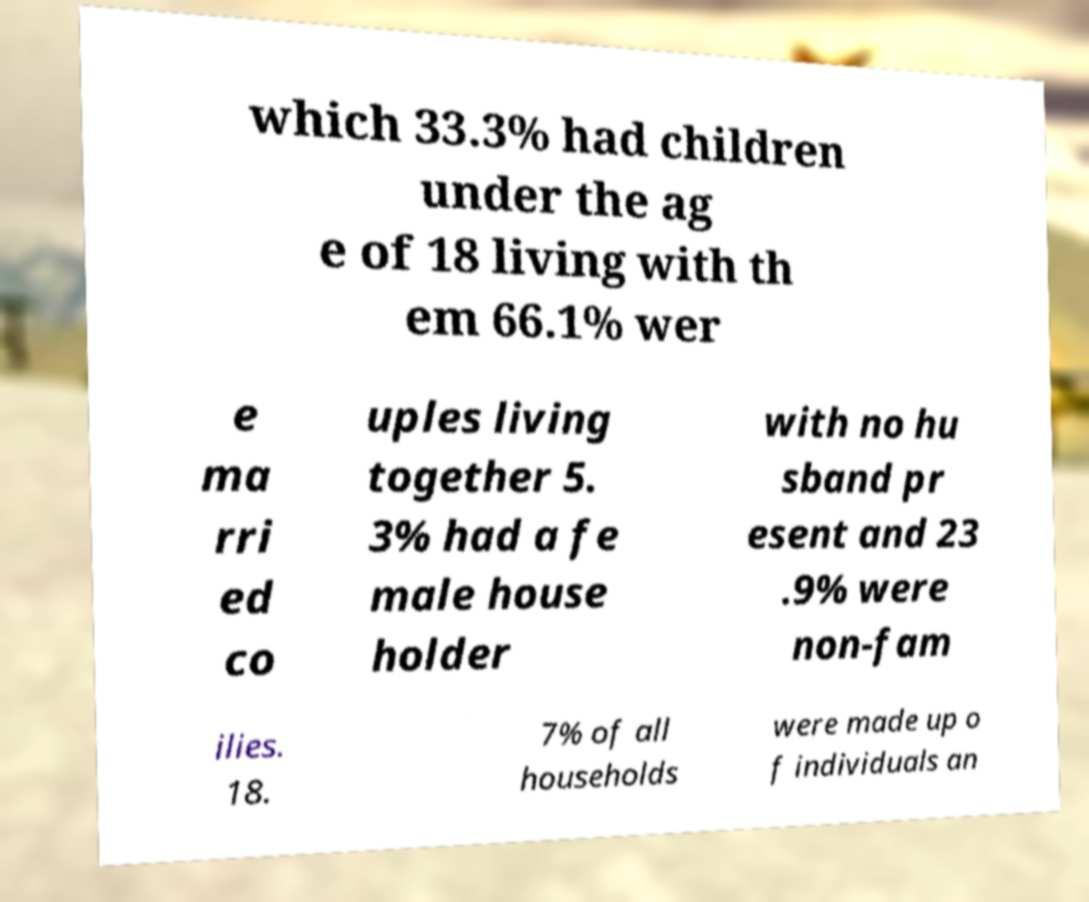I need the written content from this picture converted into text. Can you do that? which 33.3% had children under the ag e of 18 living with th em 66.1% wer e ma rri ed co uples living together 5. 3% had a fe male house holder with no hu sband pr esent and 23 .9% were non-fam ilies. 18. 7% of all households were made up o f individuals an 